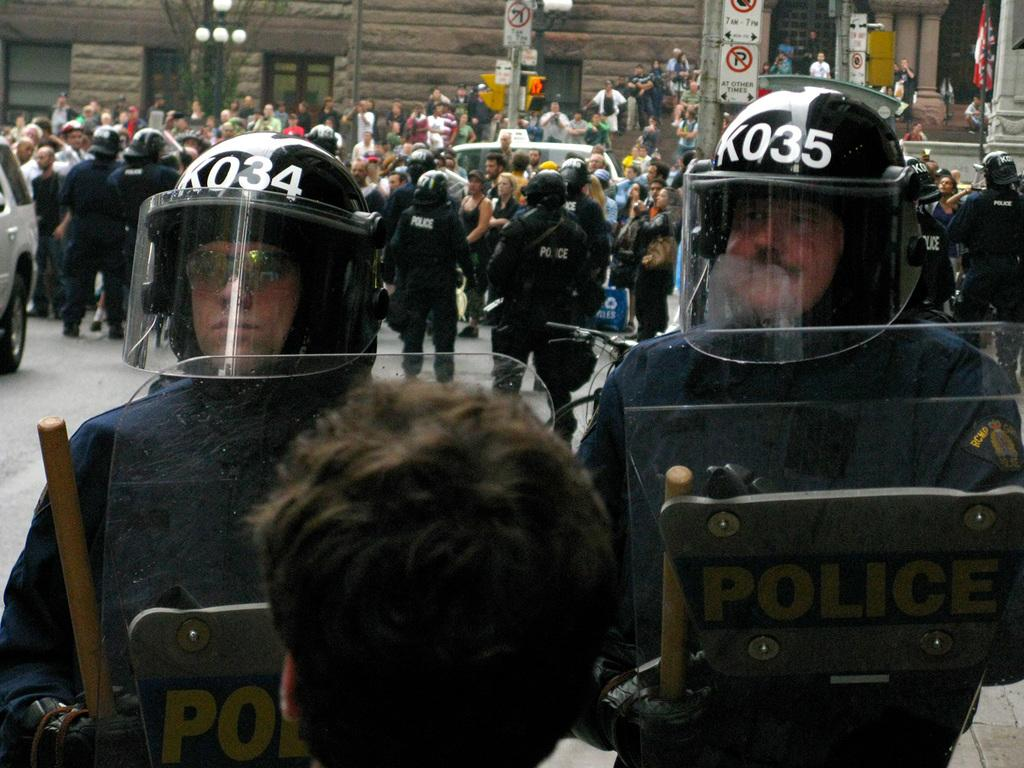What are the people in the image doing? The people in the image are standing on the road. What objects are the people holding in their hands? The people are holding sticks in their hands. What can be seen in the distance behind the people? There is a building visible in the background. What is the grandmother's voice like in the image? There is no grandmother present in the image, so it is not possible to determine her voice. 